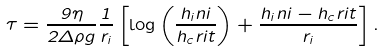Convert formula to latex. <formula><loc_0><loc_0><loc_500><loc_500>\tau = \frac { 9 \eta } { 2 \Delta \rho g } \frac { 1 } { r _ { i } } \left [ \log \left ( \frac { h _ { i } n i } { h _ { c } r i t } \right ) + \frac { h _ { i } n i - h _ { c } r i t } { r _ { i } } \right ] .</formula> 